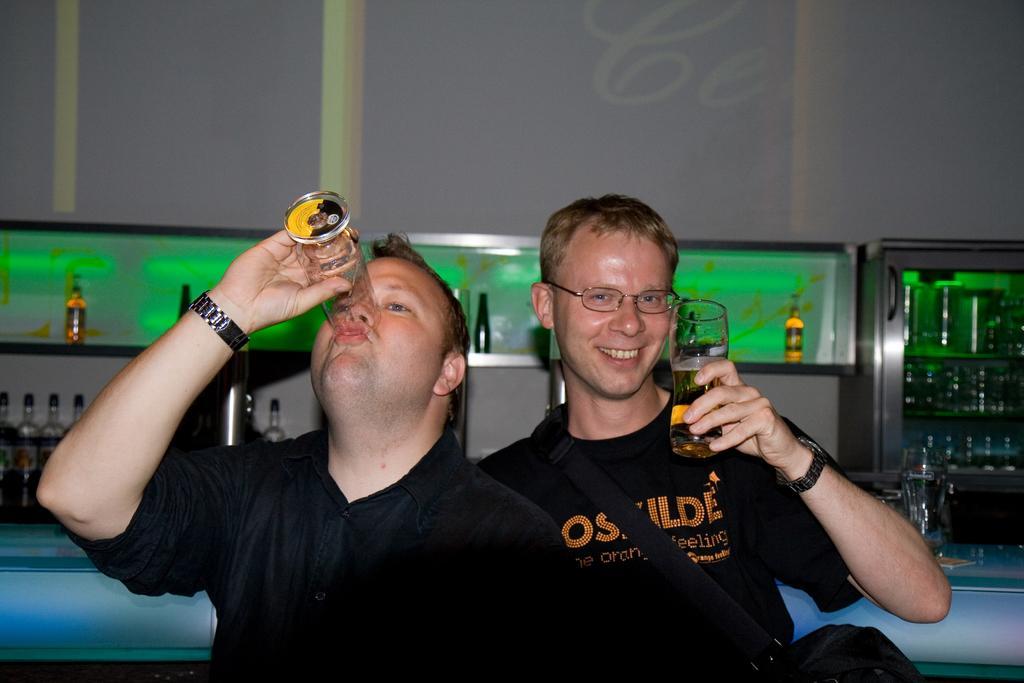Could you give a brief overview of what you see in this image? In the center we can see two persons were standing. The left man he is holding glass and the right person he is also holding glass and back pack. In the background we can see fridge with water bottles,wall,shelf,table and few wine bottles. 